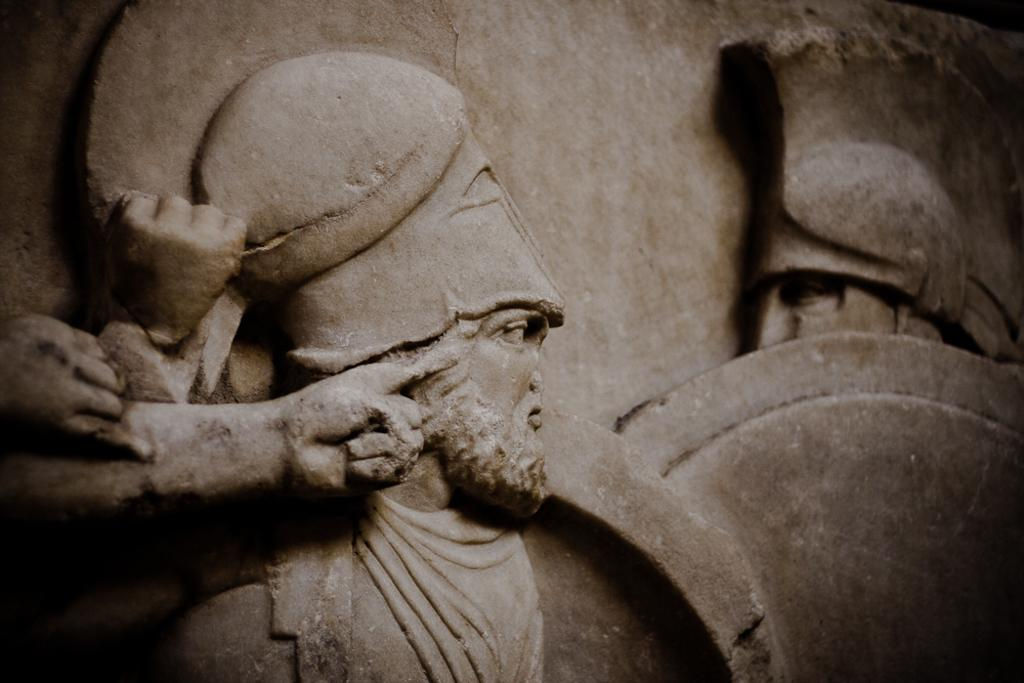What is depicted on the wall in the image? There are sculptures on the wall in the image. How many apples are being held by the sculptures in the image? There are no apples present in the image; it features sculptures on the wall. What type of books can be seen on the shelves near the sculptures in the image? There are no shelves or books present in the image; it features sculptures on the wall. 